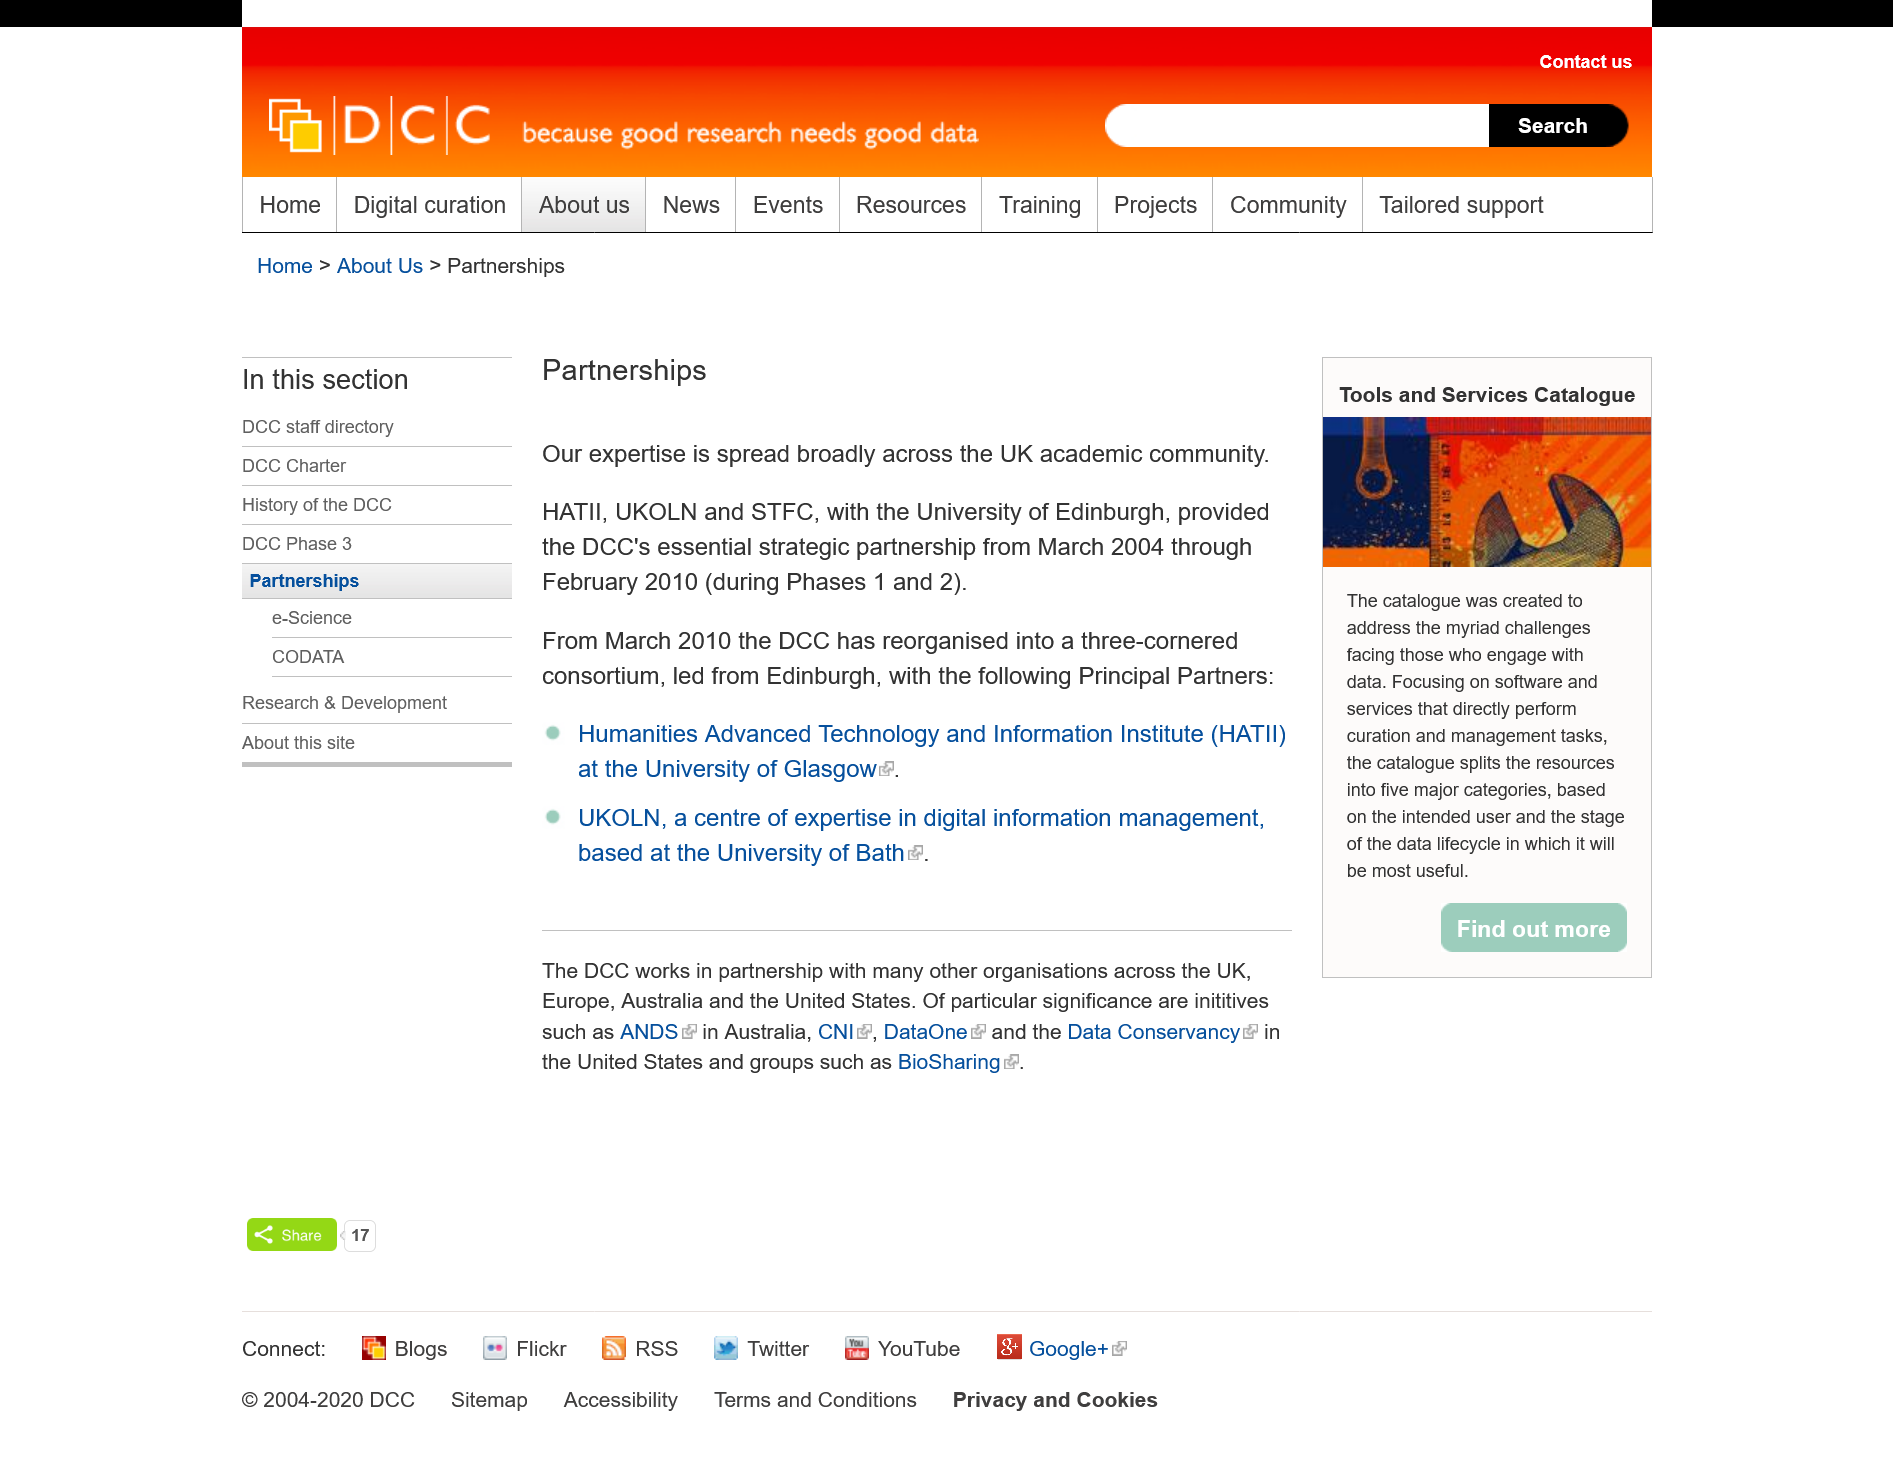Draw attention to some important aspects in this diagram. The UKOLN is located at the University of Bath, as it is a division of the institution. The Humanities Advanced Technology and Information Institute (HATII) is a research institute that specializes in the intersection of humanities, technology, and information. The article "Partnership" outlines the instances in which DCC collaborates with other organizations, specifically naming the United Kingdom, Europe, Australia, and the United States as countries where the company has partnered with its counterparts. 